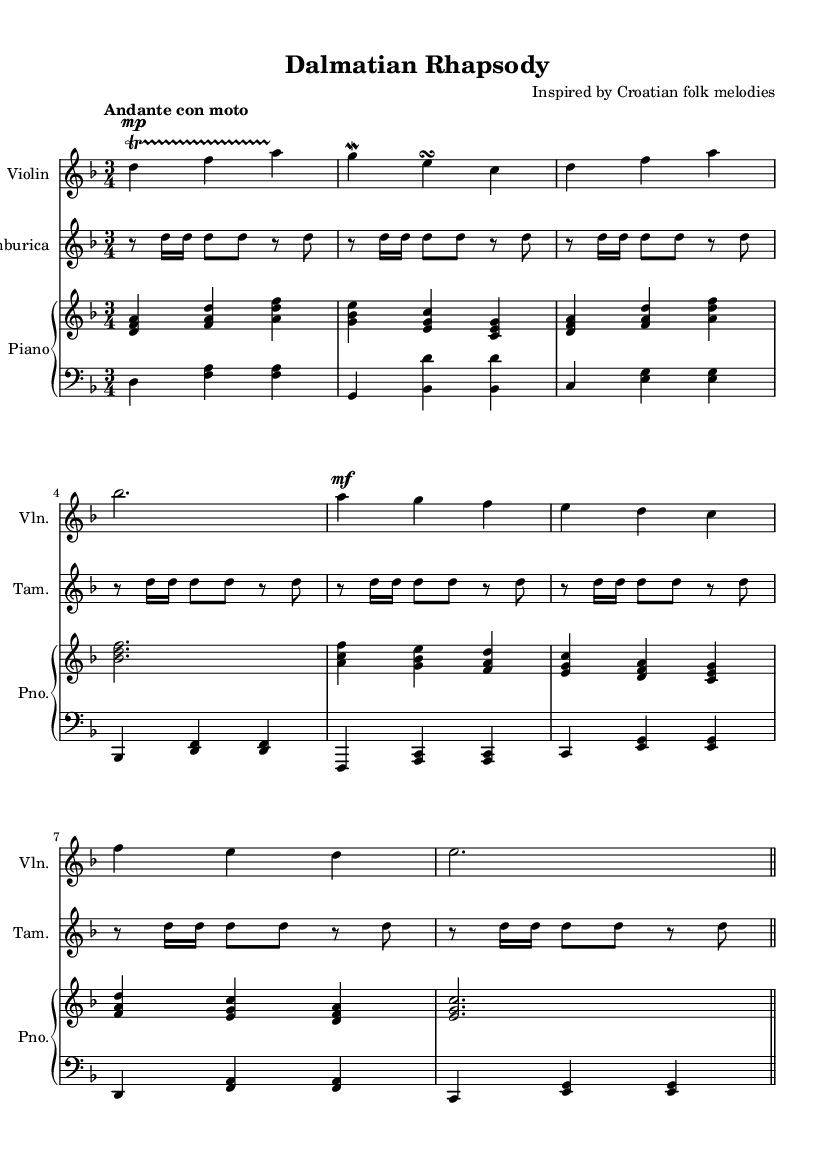What is the key signature of this music? The key signature appears as two flats, which indicates that the music is in D minor. D minor has one sharp (C) to be flattened, and consequently, it has two flats that are B flat and E flat, which is confirmed by looking at the beginning of the music.
Answer: D minor What is the time signature of this piece? The time signature is indicated at the beginning of the score and shows that there are three beats per measure. The fraction 3/4 suggests that each measure contains three quarter-note beats.
Answer: 3/4 What is the tempo marking for this composition? The tempo marking is displayed under the global settings and says "Andante con moto," indicating a moderately slow and flowing speed for the piece.
Answer: Andante con moto What type of instrument is the "tamburica"? The tamburica is labeled in the score and is a traditional string instrument from Croatia, which is typically associated with folk music. The name appears in the staff section indicating its function in the composition.
Answer: String instrument How many different instruments are featured in this score? By counting the different staves at the beginning of the score, we identify the violin, tamburica, and piano as separate instruments, leading to a total of three unique instruments in this composition.
Answer: Three What does the use of trills indicate in the violin part? The presence of a trill between the notes at the beginning indicates a decorative flourish, commonly used in Romantic music to express emotion and ornamentation, enhancing the melodic line.
Answer: Ornamentation 